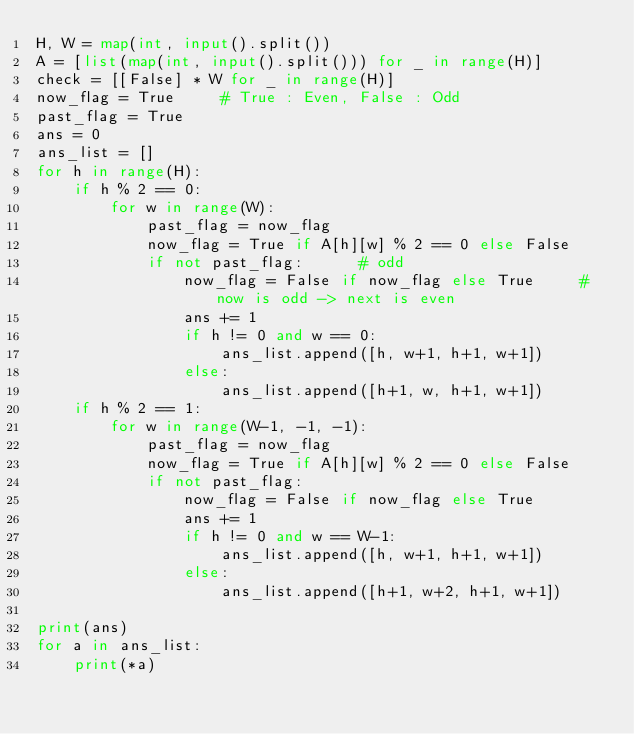<code> <loc_0><loc_0><loc_500><loc_500><_Python_>H, W = map(int, input().split())
A = [list(map(int, input().split())) for _ in range(H)]
check = [[False] * W for _ in range(H)]
now_flag = True     # True : Even, False : Odd
past_flag = True
ans = 0
ans_list = []
for h in range(H):
    if h % 2 == 0:
        for w in range(W):
            past_flag = now_flag
            now_flag = True if A[h][w] % 2 == 0 else False
            if not past_flag:      # odd
                now_flag = False if now_flag else True     # now is odd -> next is even
                ans += 1
                if h != 0 and w == 0:
                    ans_list.append([h, w+1, h+1, w+1])
                else:
                    ans_list.append([h+1, w, h+1, w+1])
    if h % 2 == 1:
        for w in range(W-1, -1, -1):
            past_flag = now_flag
            now_flag = True if A[h][w] % 2 == 0 else False
            if not past_flag:
                now_flag = False if now_flag else True
                ans += 1
                if h != 0 and w == W-1:
                    ans_list.append([h, w+1, h+1, w+1])
                else:
                    ans_list.append([h+1, w+2, h+1, w+1])

print(ans)
for a in ans_list:
    print(*a)
            </code> 